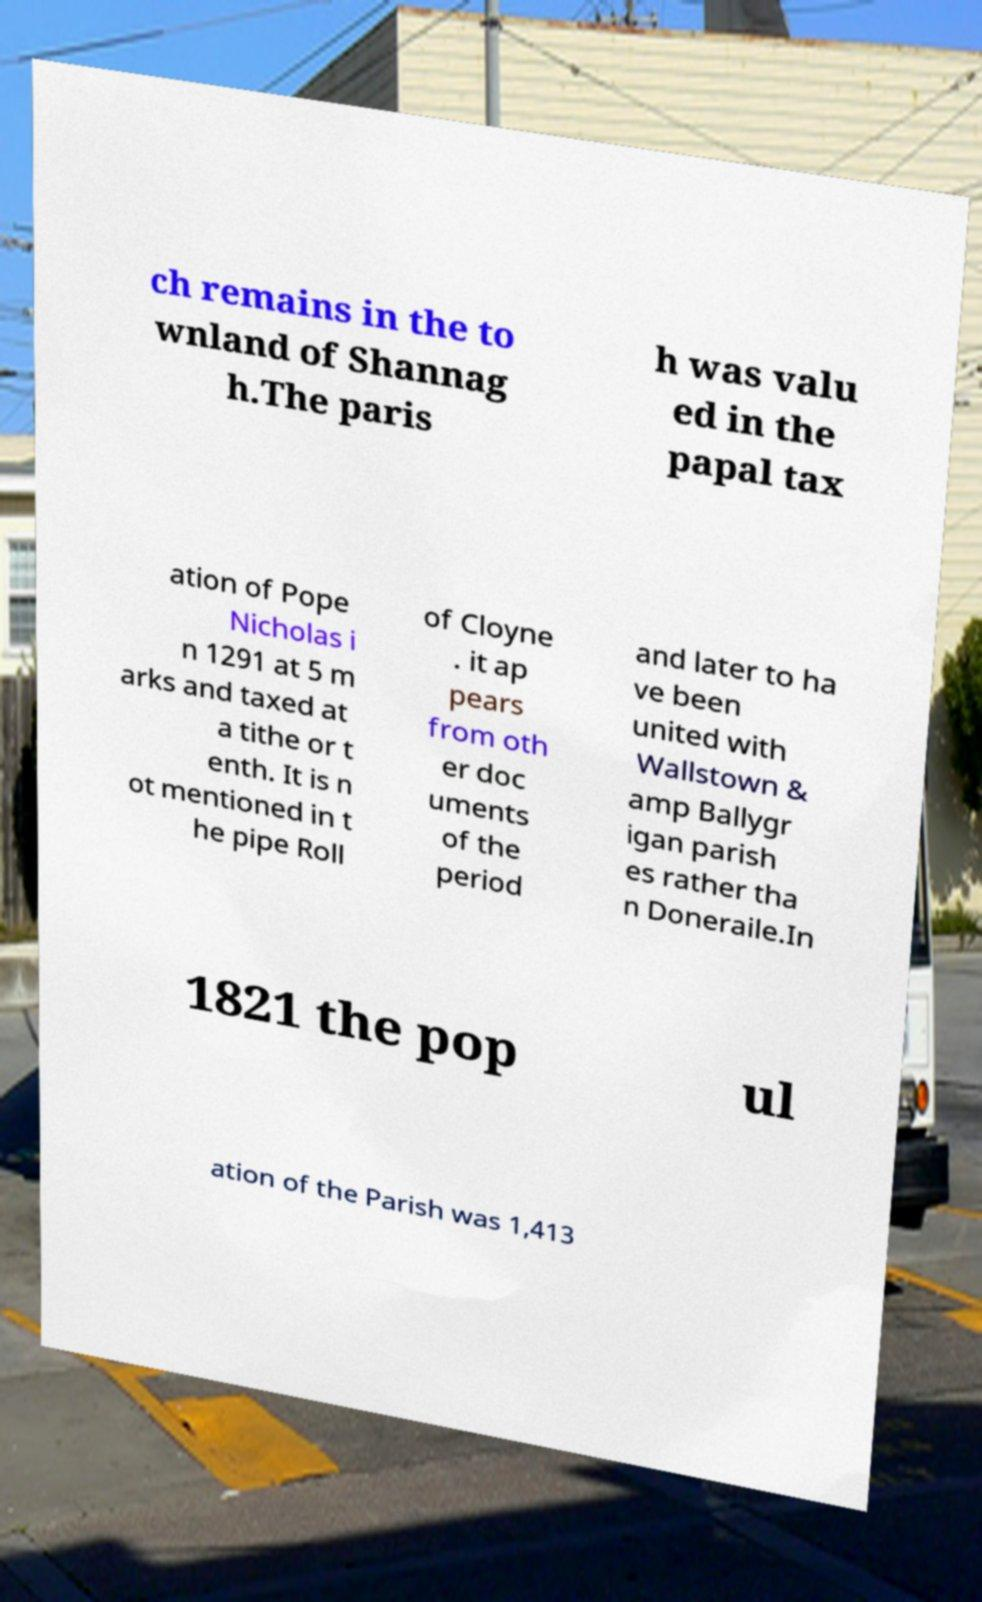What messages or text are displayed in this image? I need them in a readable, typed format. ch remains in the to wnland of Shannag h.The paris h was valu ed in the papal tax ation of Pope Nicholas i n 1291 at 5 m arks and taxed at a tithe or t enth. It is n ot mentioned in t he pipe Roll of Cloyne . it ap pears from oth er doc uments of the period and later to ha ve been united with Wallstown & amp Ballygr igan parish es rather tha n Doneraile.In 1821 the pop ul ation of the Parish was 1,413 